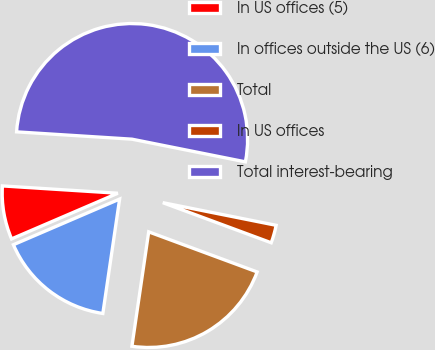<chart> <loc_0><loc_0><loc_500><loc_500><pie_chart><fcel>In US offices (5)<fcel>In offices outside the US (6)<fcel>Total<fcel>In US offices<fcel>Total interest-bearing<nl><fcel>7.47%<fcel>16.22%<fcel>21.68%<fcel>2.5%<fcel>52.13%<nl></chart> 